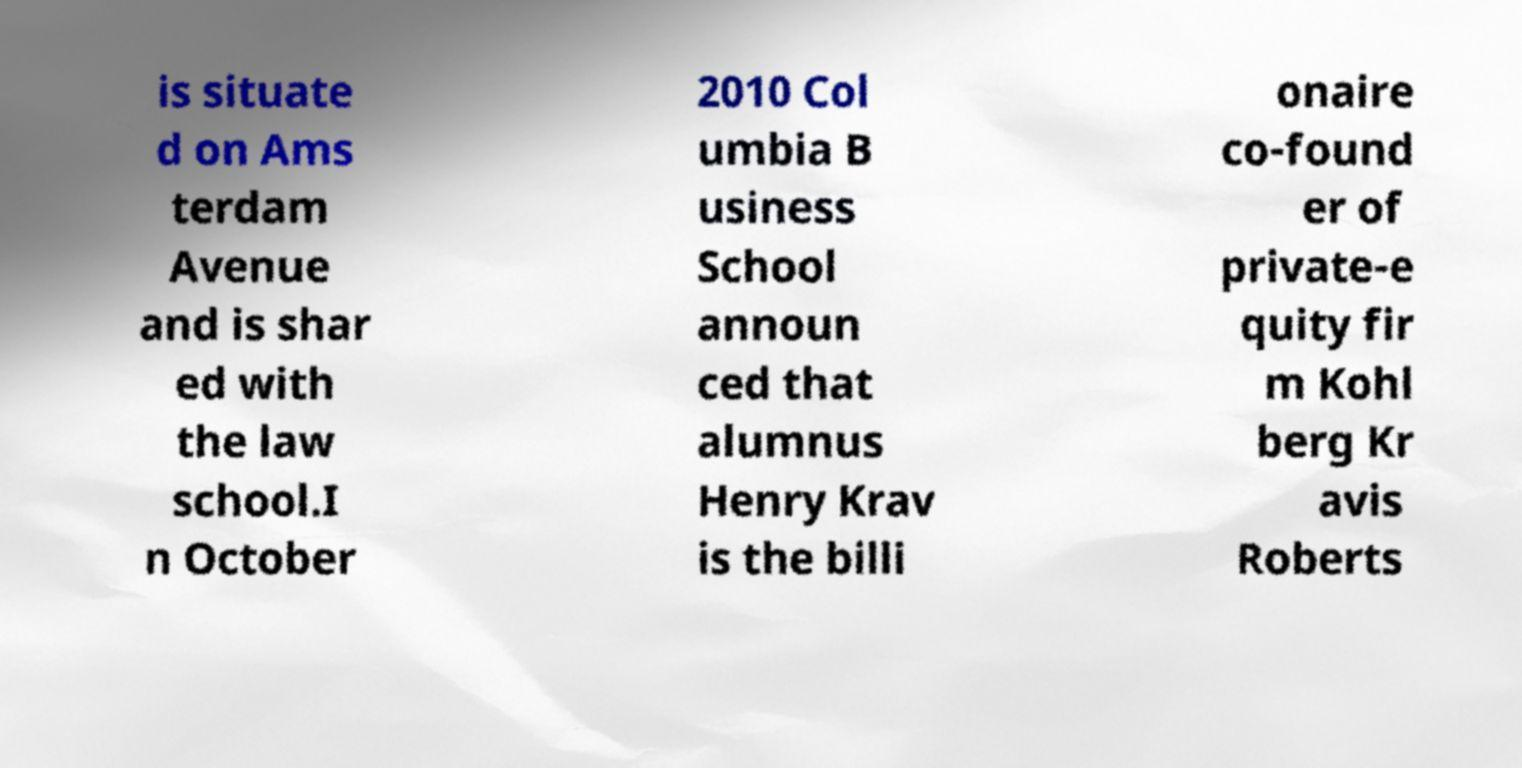Could you assist in decoding the text presented in this image and type it out clearly? is situate d on Ams terdam Avenue and is shar ed with the law school.I n October 2010 Col umbia B usiness School announ ced that alumnus Henry Krav is the billi onaire co-found er of private-e quity fir m Kohl berg Kr avis Roberts 